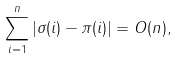Convert formula to latex. <formula><loc_0><loc_0><loc_500><loc_500>\sum _ { i = 1 } ^ { n } | \sigma ( i ) - \pi ( i ) | = O ( n ) ,</formula> 